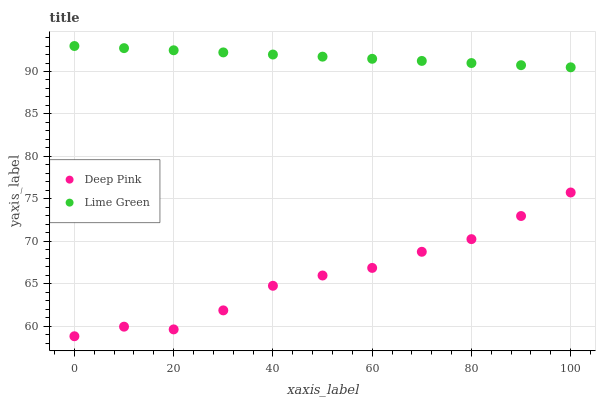Does Deep Pink have the minimum area under the curve?
Answer yes or no. Yes. Does Lime Green have the maximum area under the curve?
Answer yes or no. Yes. Does Lime Green have the minimum area under the curve?
Answer yes or no. No. Is Lime Green the smoothest?
Answer yes or no. Yes. Is Deep Pink the roughest?
Answer yes or no. Yes. Is Lime Green the roughest?
Answer yes or no. No. Does Deep Pink have the lowest value?
Answer yes or no. Yes. Does Lime Green have the lowest value?
Answer yes or no. No. Does Lime Green have the highest value?
Answer yes or no. Yes. Is Deep Pink less than Lime Green?
Answer yes or no. Yes. Is Lime Green greater than Deep Pink?
Answer yes or no. Yes. Does Deep Pink intersect Lime Green?
Answer yes or no. No. 